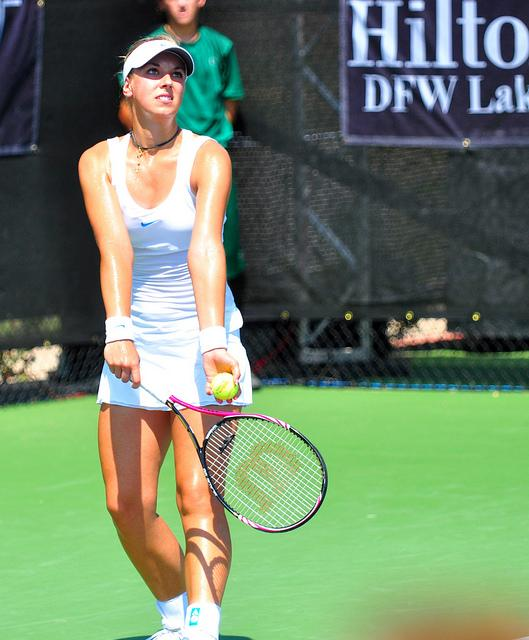Why is she holding the ball?

Choices:
A) will serve
B) for sale
C) hiding it
D) will throw will serve 